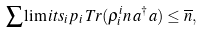<formula> <loc_0><loc_0><loc_500><loc_500>\sum \lim i t s _ { i } { p _ { i } \, T r ( \rho _ { i } ^ { i } n \, a ^ { \dagger } a ) } \leq \overline { n } ,</formula> 